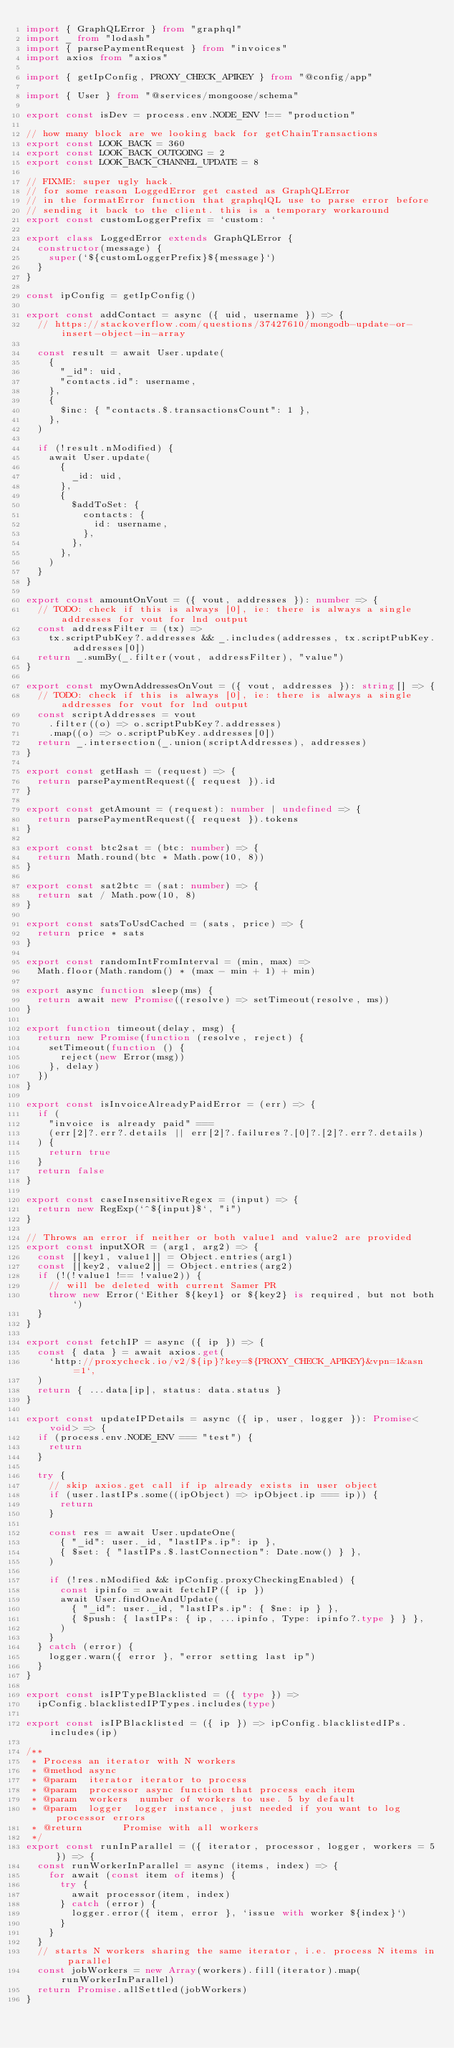<code> <loc_0><loc_0><loc_500><loc_500><_TypeScript_>import { GraphQLError } from "graphql"
import _ from "lodash"
import { parsePaymentRequest } from "invoices"
import axios from "axios"

import { getIpConfig, PROXY_CHECK_APIKEY } from "@config/app"

import { User } from "@services/mongoose/schema"

export const isDev = process.env.NODE_ENV !== "production"

// how many block are we looking back for getChainTransactions
export const LOOK_BACK = 360
export const LOOK_BACK_OUTGOING = 2
export const LOOK_BACK_CHANNEL_UPDATE = 8

// FIXME: super ugly hack.
// for some reason LoggedError get casted as GraphQLError
// in the formatError function that graphqlQL use to parse error before
// sending it back to the client. this is a temporary workaround
export const customLoggerPrefix = `custom: `

export class LoggedError extends GraphQLError {
  constructor(message) {
    super(`${customLoggerPrefix}${message}`)
  }
}

const ipConfig = getIpConfig()

export const addContact = async ({ uid, username }) => {
  // https://stackoverflow.com/questions/37427610/mongodb-update-or-insert-object-in-array

  const result = await User.update(
    {
      "_id": uid,
      "contacts.id": username,
    },
    {
      $inc: { "contacts.$.transactionsCount": 1 },
    },
  )

  if (!result.nModified) {
    await User.update(
      {
        _id: uid,
      },
      {
        $addToSet: {
          contacts: {
            id: username,
          },
        },
      },
    )
  }
}

export const amountOnVout = ({ vout, addresses }): number => {
  // TODO: check if this is always [0], ie: there is always a single addresses for vout for lnd output
  const addressFilter = (tx) =>
    tx.scriptPubKey?.addresses && _.includes(addresses, tx.scriptPubKey.addresses[0])
  return _.sumBy(_.filter(vout, addressFilter), "value")
}

export const myOwnAddressesOnVout = ({ vout, addresses }): string[] => {
  // TODO: check if this is always [0], ie: there is always a single addresses for vout for lnd output
  const scriptAddresses = vout
    .filter((o) => o.scriptPubKey?.addresses)
    .map((o) => o.scriptPubKey.addresses[0])
  return _.intersection(_.union(scriptAddresses), addresses)
}

export const getHash = (request) => {
  return parsePaymentRequest({ request }).id
}

export const getAmount = (request): number | undefined => {
  return parsePaymentRequest({ request }).tokens
}

export const btc2sat = (btc: number) => {
  return Math.round(btc * Math.pow(10, 8))
}

export const sat2btc = (sat: number) => {
  return sat / Math.pow(10, 8)
}

export const satsToUsdCached = (sats, price) => {
  return price * sats
}

export const randomIntFromInterval = (min, max) =>
  Math.floor(Math.random() * (max - min + 1) + min)

export async function sleep(ms) {
  return await new Promise((resolve) => setTimeout(resolve, ms))
}

export function timeout(delay, msg) {
  return new Promise(function (resolve, reject) {
    setTimeout(function () {
      reject(new Error(msg))
    }, delay)
  })
}

export const isInvoiceAlreadyPaidError = (err) => {
  if (
    "invoice is already paid" ===
    (err[2]?.err?.details || err[2]?.failures?.[0]?.[2]?.err?.details)
  ) {
    return true
  }
  return false
}

export const caseInsensitiveRegex = (input) => {
  return new RegExp(`^${input}$`, "i")
}

// Throws an error if neither or both value1 and value2 are provided
export const inputXOR = (arg1, arg2) => {
  const [[key1, value1]] = Object.entries(arg1)
  const [[key2, value2]] = Object.entries(arg2)
  if (!(!value1 !== !value2)) {
    // will be deleted with current Samer PR
    throw new Error(`Either ${key1} or ${key2} is required, but not both`)
  }
}

export const fetchIP = async ({ ip }) => {
  const { data } = await axios.get(
    `http://proxycheck.io/v2/${ip}?key=${PROXY_CHECK_APIKEY}&vpn=1&asn=1`,
  )
  return { ...data[ip], status: data.status }
}

export const updateIPDetails = async ({ ip, user, logger }): Promise<void> => {
  if (process.env.NODE_ENV === "test") {
    return
  }

  try {
    // skip axios.get call if ip already exists in user object
    if (user.lastIPs.some((ipObject) => ipObject.ip === ip)) {
      return
    }

    const res = await User.updateOne(
      { "_id": user._id, "lastIPs.ip": ip },
      { $set: { "lastIPs.$.lastConnection": Date.now() } },
    )

    if (!res.nModified && ipConfig.proxyCheckingEnabled) {
      const ipinfo = await fetchIP({ ip })
      await User.findOneAndUpdate(
        { "_id": user._id, "lastIPs.ip": { $ne: ip } },
        { $push: { lastIPs: { ip, ...ipinfo, Type: ipinfo?.type } } },
      )
    }
  } catch (error) {
    logger.warn({ error }, "error setting last ip")
  }
}

export const isIPTypeBlacklisted = ({ type }) =>
  ipConfig.blacklistedIPTypes.includes(type)

export const isIPBlacklisted = ({ ip }) => ipConfig.blacklistedIPs.includes(ip)

/**
 * Process an iterator with N workers
 * @method async
 * @param  iterator iterator to process
 * @param  processor async function that process each item
 * @param  workers  number of workers to use. 5 by default
 * @param  logger  logger instance, just needed if you want to log processor errors
 * @return       Promise with all workers
 */
export const runInParallel = ({ iterator, processor, logger, workers = 5 }) => {
  const runWorkerInParallel = async (items, index) => {
    for await (const item of items) {
      try {
        await processor(item, index)
      } catch (error) {
        logger.error({ item, error }, `issue with worker ${index}`)
      }
    }
  }
  // starts N workers sharing the same iterator, i.e. process N items in parallel
  const jobWorkers = new Array(workers).fill(iterator).map(runWorkerInParallel)
  return Promise.allSettled(jobWorkers)
}
</code> 